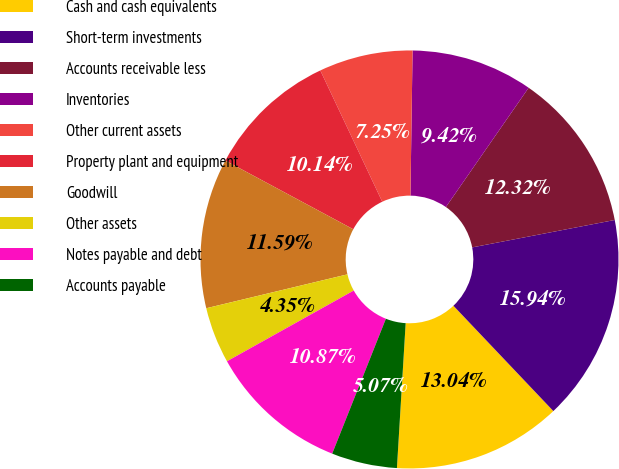<chart> <loc_0><loc_0><loc_500><loc_500><pie_chart><fcel>Cash and cash equivalents<fcel>Short-term investments<fcel>Accounts receivable less<fcel>Inventories<fcel>Other current assets<fcel>Property plant and equipment<fcel>Goodwill<fcel>Other assets<fcel>Notes payable and debt<fcel>Accounts payable<nl><fcel>13.04%<fcel>15.94%<fcel>12.32%<fcel>9.42%<fcel>7.25%<fcel>10.14%<fcel>11.59%<fcel>4.35%<fcel>10.87%<fcel>5.07%<nl></chart> 